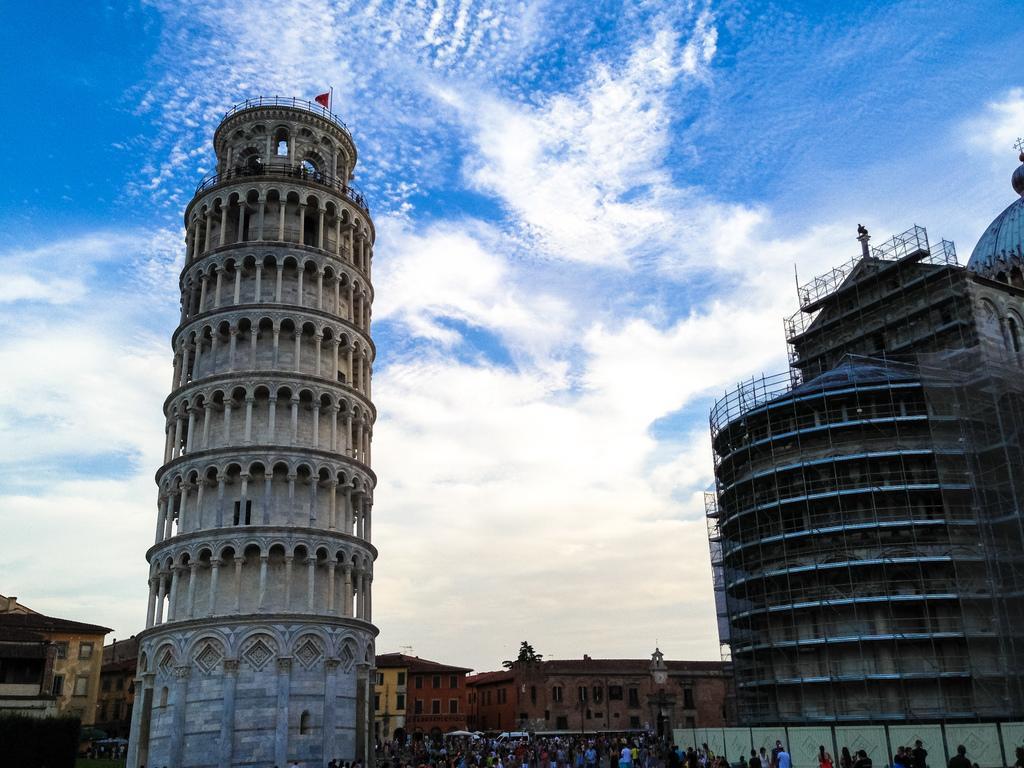Describe this image in one or two sentences. In this image there are buildings, cloudy sky, people, tree and objects. 